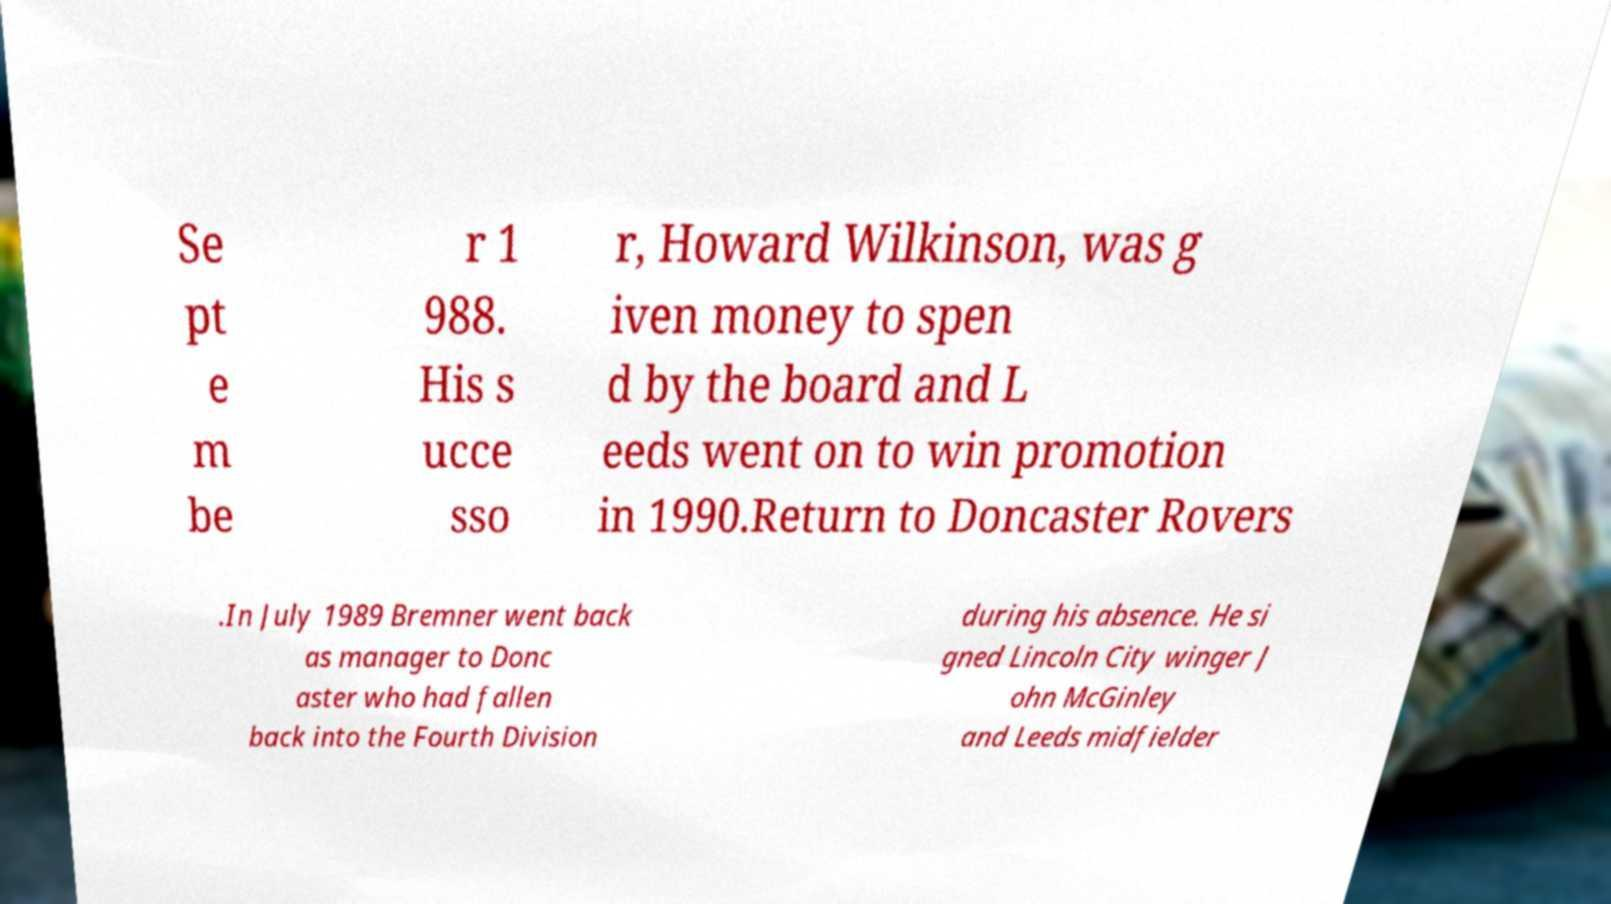Could you extract and type out the text from this image? Se pt e m be r 1 988. His s ucce sso r, Howard Wilkinson, was g iven money to spen d by the board and L eeds went on to win promotion in 1990.Return to Doncaster Rovers .In July 1989 Bremner went back as manager to Donc aster who had fallen back into the Fourth Division during his absence. He si gned Lincoln City winger J ohn McGinley and Leeds midfielder 